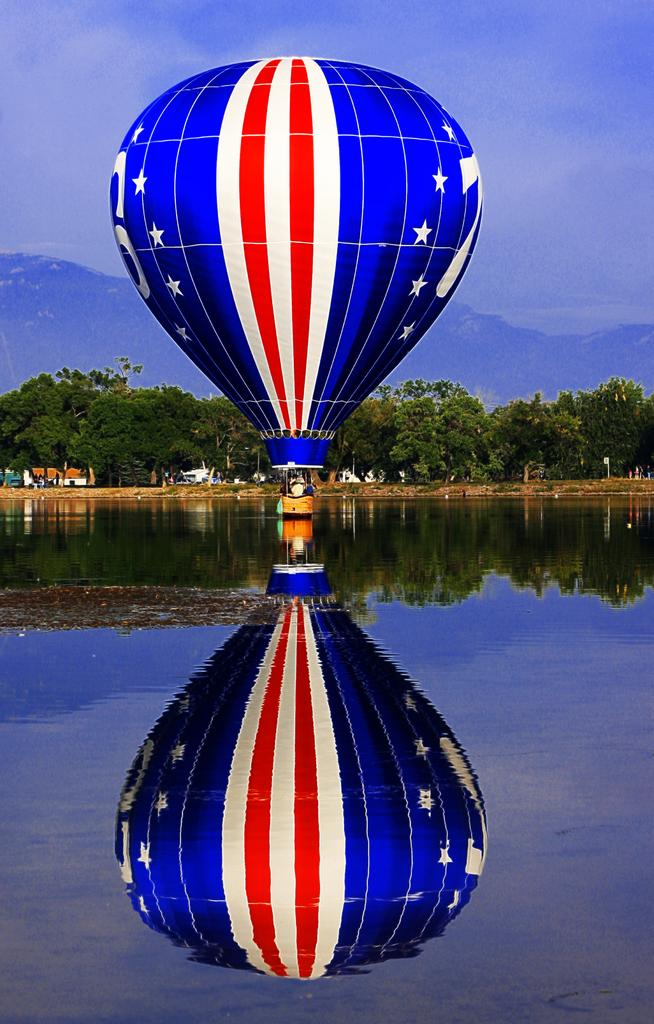What is floating on the water in the image? There is a parachute on the water. What type of structures can be seen in the image? There are buildings in the image. What type of natural environment is visible in the image? There are trees and mountains in the image. What type of art is displayed on the parachute in the image? There is no art displayed on the parachute in the image; it is simply a parachute floating on the water. 